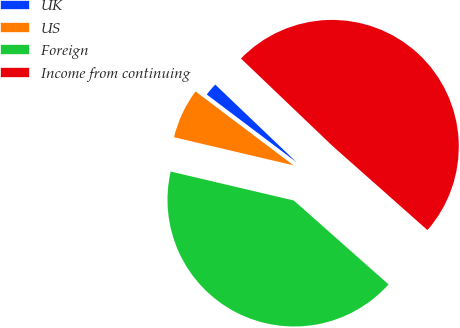Convert chart. <chart><loc_0><loc_0><loc_500><loc_500><pie_chart><fcel>UK<fcel>US<fcel>Foreign<fcel>Income from continuing<nl><fcel>1.85%<fcel>6.61%<fcel>42.14%<fcel>49.41%<nl></chart> 